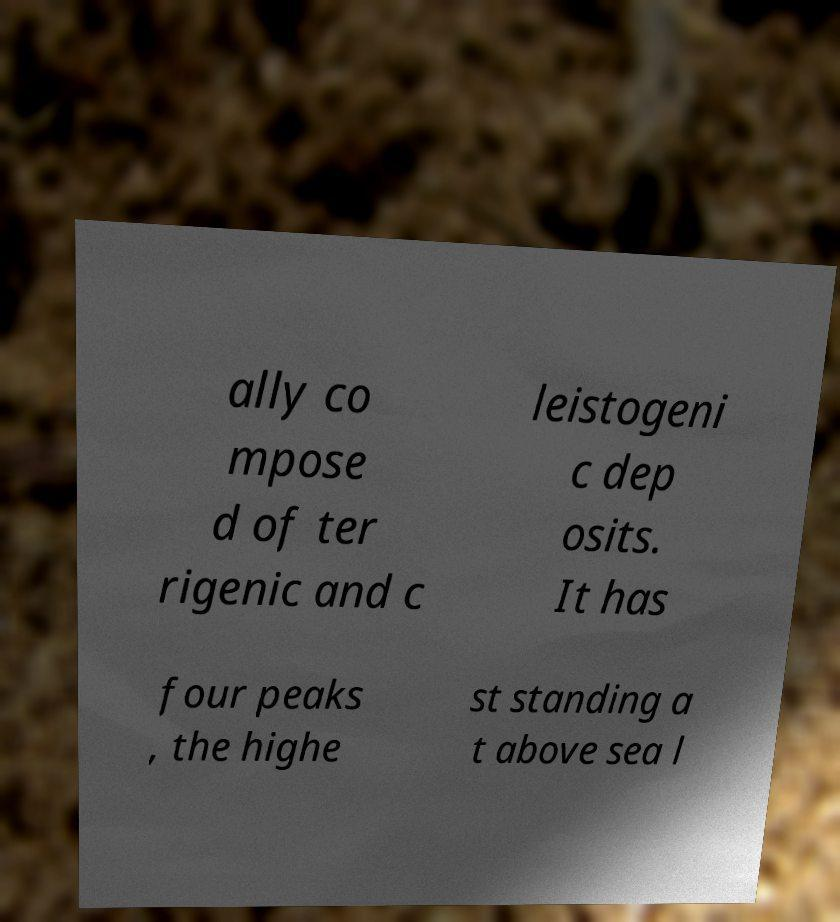Please identify and transcribe the text found in this image. ally co mpose d of ter rigenic and c leistogeni c dep osits. It has four peaks , the highe st standing a t above sea l 